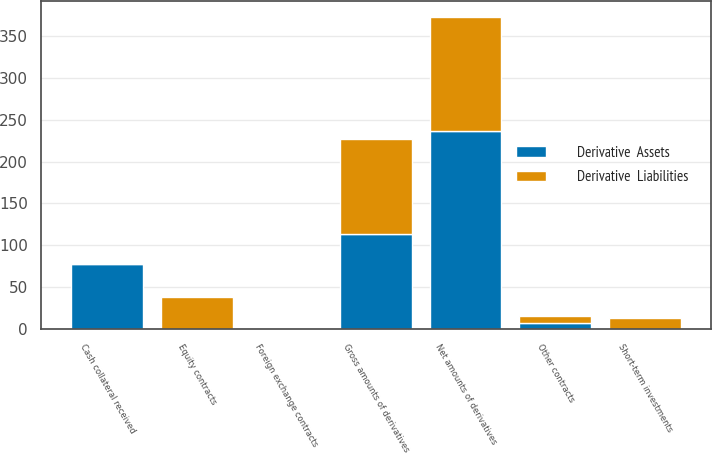<chart> <loc_0><loc_0><loc_500><loc_500><stacked_bar_chart><ecel><fcel>Foreign exchange contracts<fcel>Equity contracts<fcel>Other contracts<fcel>Gross amounts of derivatives<fcel>Cash collateral received<fcel>Net amounts of derivatives<fcel>Short-term investments<nl><fcel>Derivative  Liabilities<fcel>0<fcel>38<fcel>8<fcel>113<fcel>0<fcel>137<fcel>13<nl><fcel>Derivative  Assets<fcel>0<fcel>0<fcel>7<fcel>114<fcel>78<fcel>236<fcel>0<nl></chart> 